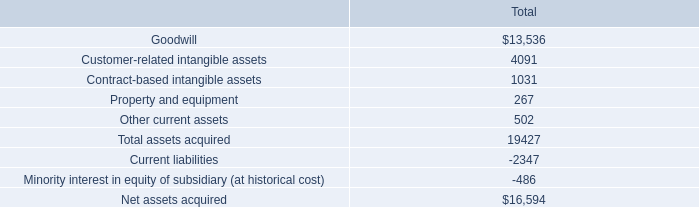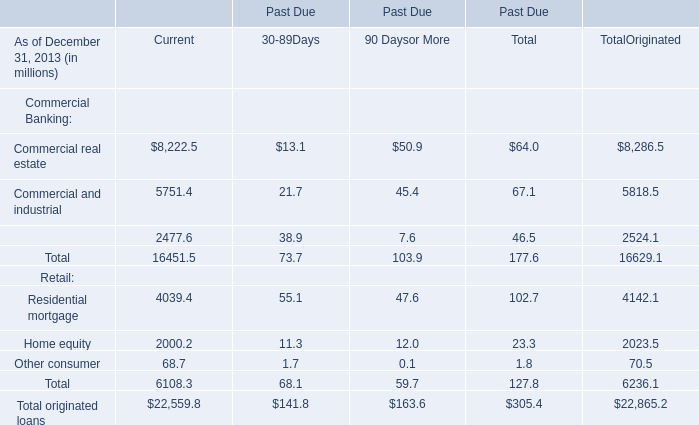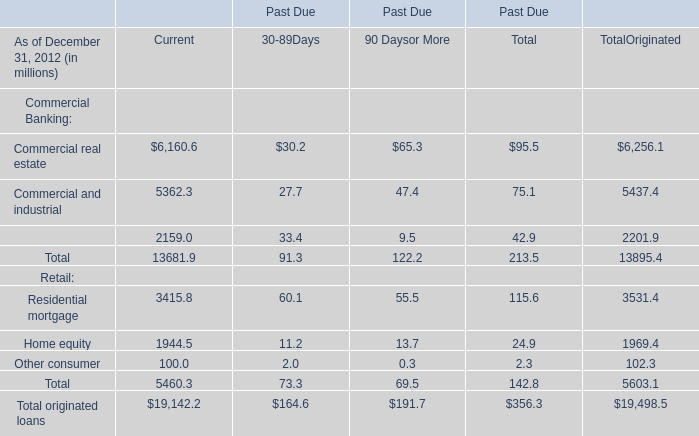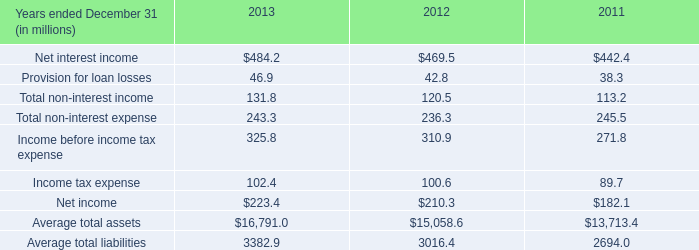How many Retail exceed the average of Commercial Banking for TotalOriginated in 2012?" 
Answer: 0. 